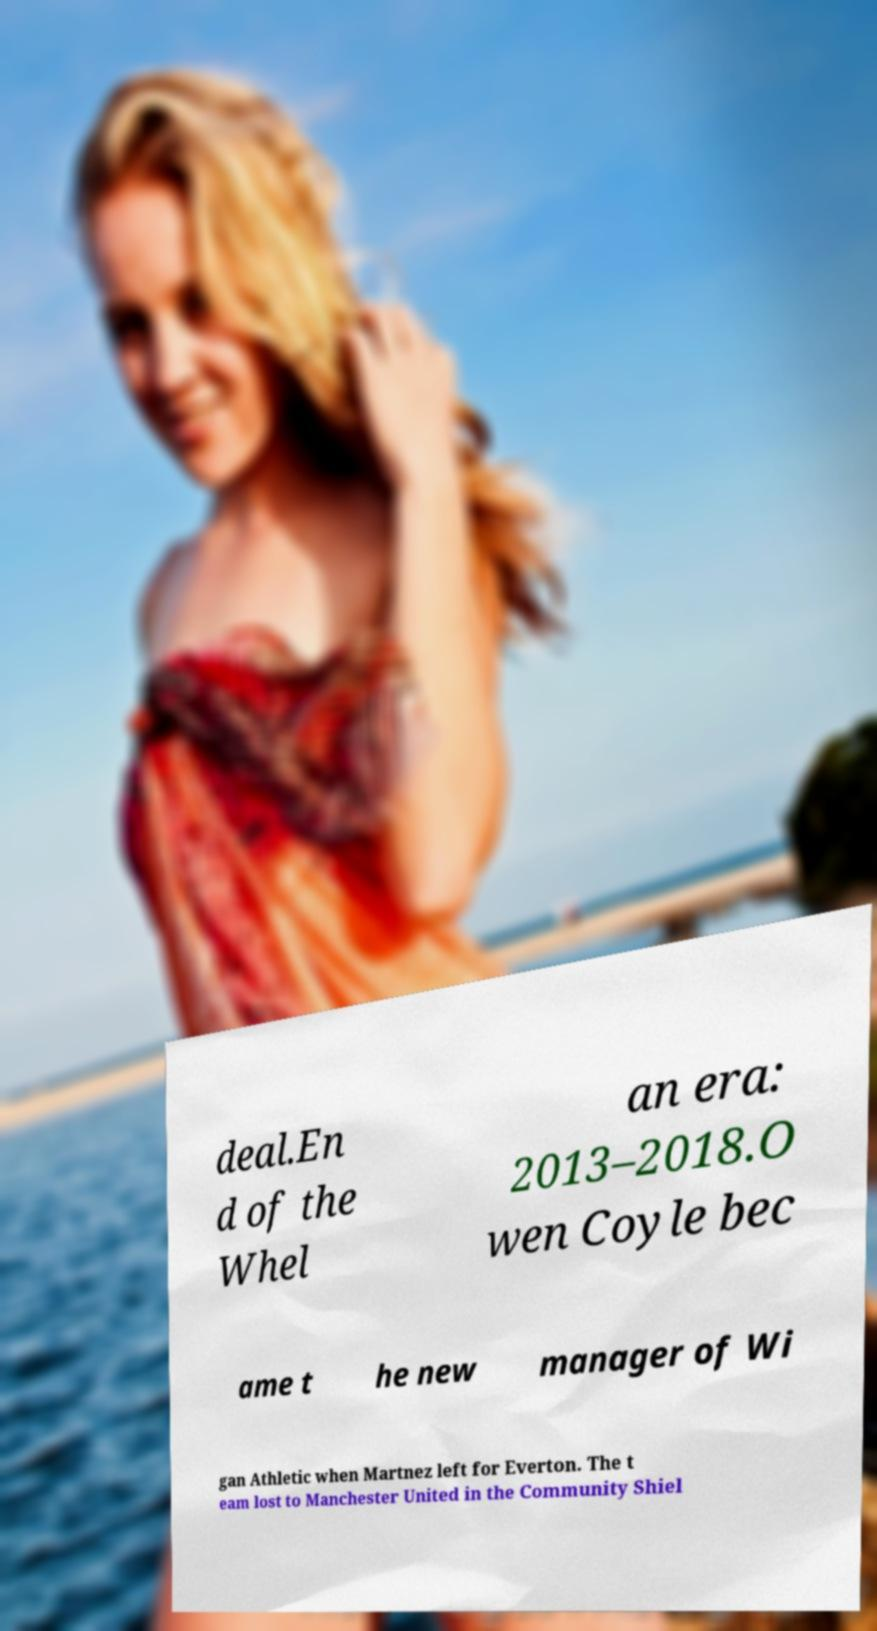Please read and relay the text visible in this image. What does it say? deal.En d of the Whel an era: 2013–2018.O wen Coyle bec ame t he new manager of Wi gan Athletic when Martnez left for Everton. The t eam lost to Manchester United in the Community Shiel 